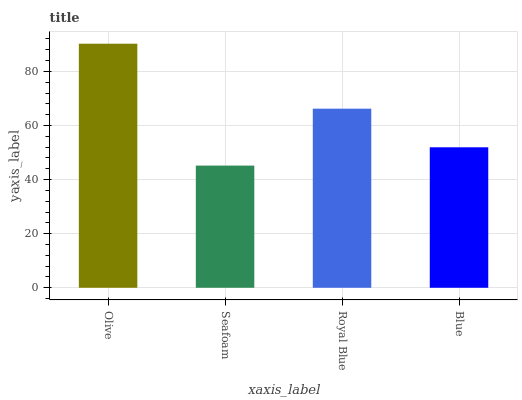Is Seafoam the minimum?
Answer yes or no. Yes. Is Olive the maximum?
Answer yes or no. Yes. Is Royal Blue the minimum?
Answer yes or no. No. Is Royal Blue the maximum?
Answer yes or no. No. Is Royal Blue greater than Seafoam?
Answer yes or no. Yes. Is Seafoam less than Royal Blue?
Answer yes or no. Yes. Is Seafoam greater than Royal Blue?
Answer yes or no. No. Is Royal Blue less than Seafoam?
Answer yes or no. No. Is Royal Blue the high median?
Answer yes or no. Yes. Is Blue the low median?
Answer yes or no. Yes. Is Blue the high median?
Answer yes or no. No. Is Royal Blue the low median?
Answer yes or no. No. 